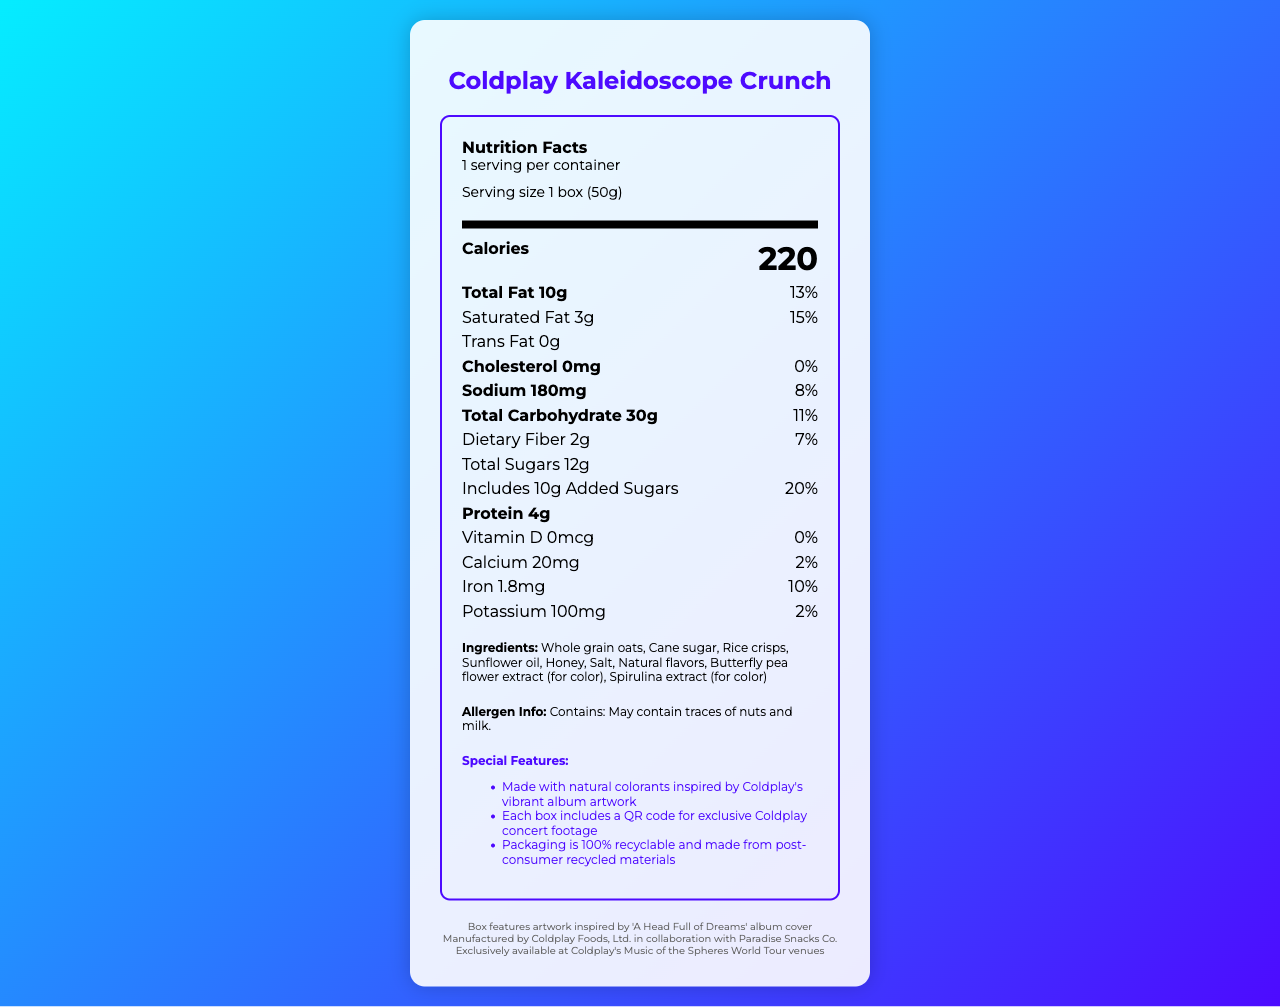What is the serving size of Coldplay Kaleidoscope Crunch? The serving size is indicated as "1 box (50g)" in the serving information section.
Answer: 1 box (50g) How many calories are in one serving of Coldplay Kaleidoscope Crunch? The nutrient section lists the amount of calories per serving as "220".
Answer: 220 calories What percentage of the daily value is the total fat in this snack? The nutrition facts label lists the total fat as "10g" and the daily value as "13%".
Answer: 13% Name two natural colorants used in Coldplay Kaleidoscope Crunch. Under the ingredients section, it mentions "Butterfly pea flower extract" and "Spirulina extract" as natural colorants.
Answer: Butterfly pea flower extract, Spirulina extract What is the sodium content in milligrams? The nutritional content section lists sodium as "180mg".
Answer: 180mg Which album artwork is the packaging inspired by? A. Ghost Stories B. A Head Full of Dreams C. Viva La Vida D. Mylo Xyloto The packaging section states, "Box features artwork inspired by 'A Head Full of Dreams' album cover."
Answer: B Which of the following nutrients has the highest daily value percentage? i. Total Fat ii. Saturated Fat iii. Dietary Fiber iv. Added Sugars The label gives the daily value percentages as: Total Fat: 13%, Saturated Fat: 15%, Dietary Fiber: 7%, Added Sugars: 20%. Added Sugars have the highest daily value percentage.
Answer: iv Does Coldplay Kaleidoscope Crunch contain protein? (Yes/No) The nutritional section lists the protein content as "4g".
Answer: Yes Summarize the main features of Coldplay Kaleidoscope Crunch. The document provides detailed nutritional information, special aspects like natural colorants, packaging inspired by Coldplay's album artwork, and exclusive concert footage through a QR code.
Answer: Coldplay Kaleidoscope Crunch is a limited edition snack featuring artistic elements from Coldplay's 'A Head Full of Dreams' album cover. It provides 220 calories per 50g serving with notable amounts of fat, carbs, and sugars but contains natural ingredients and colorants. Special features include a recyclable packaging and an exclusive QR code for concert footage. What is the exact amount of Vitamin D in the product? The vitamin section lists Vitamin D content as "0mcg".
Answer: 0mcg Who is the manufacturer of Coldplay Kaleidoscope Crunch? The footer of the document states the manufacturer as "Coldplay Foods, Ltd. in collaboration with Paradise Snacks Co."
Answer: Coldplay Foods, Ltd. in collaboration with Paradise Snacks Co. Can you determine the price of Coldplay Kaleidoscope Crunch from the document? The document does not provide any details on the price of the product.
Answer: Not enough information 